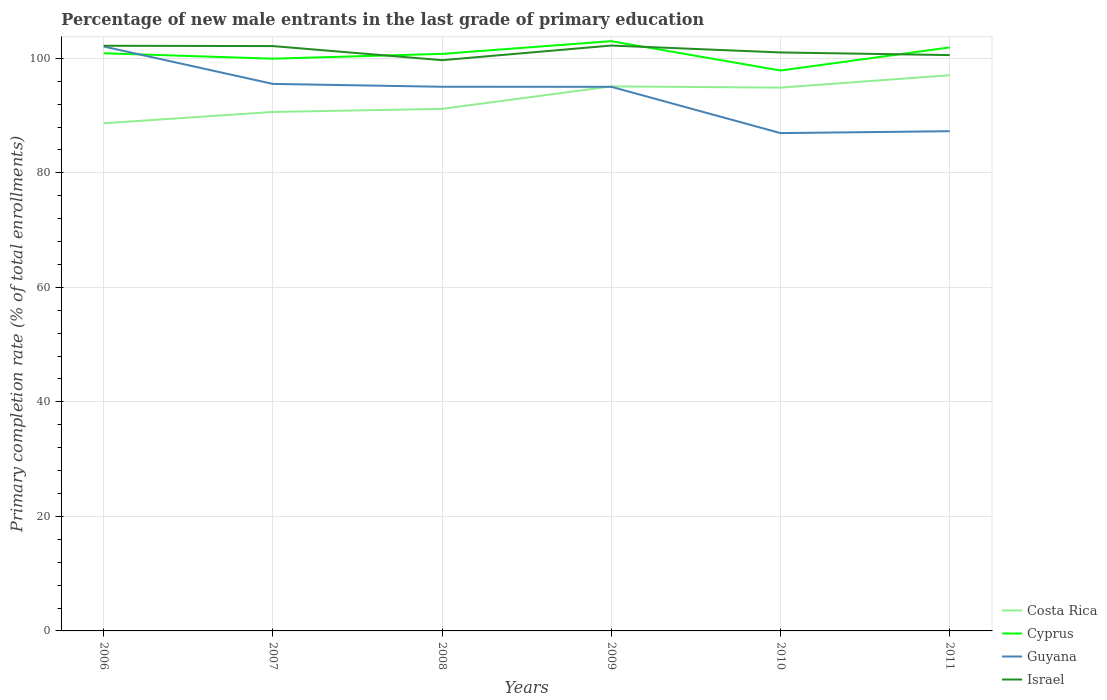How many different coloured lines are there?
Provide a short and direct response. 4. Does the line corresponding to Costa Rica intersect with the line corresponding to Israel?
Your answer should be compact. No. Across all years, what is the maximum percentage of new male entrants in Cyprus?
Offer a very short reply. 97.88. In which year was the percentage of new male entrants in Israel maximum?
Your answer should be very brief. 2008. What is the total percentage of new male entrants in Guyana in the graph?
Your response must be concise. -0.33. What is the difference between the highest and the second highest percentage of new male entrants in Cyprus?
Offer a very short reply. 5.12. What is the difference between the highest and the lowest percentage of new male entrants in Israel?
Your answer should be compact. 3. Is the percentage of new male entrants in Israel strictly greater than the percentage of new male entrants in Guyana over the years?
Your answer should be compact. No. How many lines are there?
Keep it short and to the point. 4. How many years are there in the graph?
Provide a succinct answer. 6. Are the values on the major ticks of Y-axis written in scientific E-notation?
Your response must be concise. No. Does the graph contain any zero values?
Provide a succinct answer. No. Does the graph contain grids?
Give a very brief answer. Yes. Where does the legend appear in the graph?
Make the answer very short. Bottom right. How many legend labels are there?
Provide a short and direct response. 4. What is the title of the graph?
Your answer should be very brief. Percentage of new male entrants in the last grade of primary education. What is the label or title of the Y-axis?
Ensure brevity in your answer.  Primary completion rate (% of total enrollments). What is the Primary completion rate (% of total enrollments) of Costa Rica in 2006?
Provide a short and direct response. 88.66. What is the Primary completion rate (% of total enrollments) of Cyprus in 2006?
Keep it short and to the point. 100.89. What is the Primary completion rate (% of total enrollments) in Guyana in 2006?
Your answer should be compact. 102.07. What is the Primary completion rate (% of total enrollments) of Israel in 2006?
Your answer should be compact. 102.2. What is the Primary completion rate (% of total enrollments) in Costa Rica in 2007?
Offer a very short reply. 90.64. What is the Primary completion rate (% of total enrollments) of Cyprus in 2007?
Offer a terse response. 99.94. What is the Primary completion rate (% of total enrollments) in Guyana in 2007?
Your response must be concise. 95.54. What is the Primary completion rate (% of total enrollments) in Israel in 2007?
Your answer should be compact. 102.15. What is the Primary completion rate (% of total enrollments) of Costa Rica in 2008?
Provide a succinct answer. 91.18. What is the Primary completion rate (% of total enrollments) of Cyprus in 2008?
Your answer should be very brief. 100.79. What is the Primary completion rate (% of total enrollments) of Guyana in 2008?
Provide a succinct answer. 95.04. What is the Primary completion rate (% of total enrollments) in Israel in 2008?
Your answer should be compact. 99.68. What is the Primary completion rate (% of total enrollments) in Costa Rica in 2009?
Provide a short and direct response. 95.1. What is the Primary completion rate (% of total enrollments) of Cyprus in 2009?
Provide a succinct answer. 103. What is the Primary completion rate (% of total enrollments) of Guyana in 2009?
Offer a terse response. 95.03. What is the Primary completion rate (% of total enrollments) of Israel in 2009?
Give a very brief answer. 102.24. What is the Primary completion rate (% of total enrollments) in Costa Rica in 2010?
Your answer should be very brief. 94.89. What is the Primary completion rate (% of total enrollments) in Cyprus in 2010?
Provide a succinct answer. 97.88. What is the Primary completion rate (% of total enrollments) of Guyana in 2010?
Your response must be concise. 86.94. What is the Primary completion rate (% of total enrollments) in Israel in 2010?
Ensure brevity in your answer.  101.03. What is the Primary completion rate (% of total enrollments) in Costa Rica in 2011?
Offer a very short reply. 97.06. What is the Primary completion rate (% of total enrollments) in Cyprus in 2011?
Ensure brevity in your answer.  101.91. What is the Primary completion rate (% of total enrollments) of Guyana in 2011?
Your answer should be compact. 87.28. What is the Primary completion rate (% of total enrollments) of Israel in 2011?
Your answer should be very brief. 100.57. Across all years, what is the maximum Primary completion rate (% of total enrollments) of Costa Rica?
Your response must be concise. 97.06. Across all years, what is the maximum Primary completion rate (% of total enrollments) in Cyprus?
Your answer should be compact. 103. Across all years, what is the maximum Primary completion rate (% of total enrollments) of Guyana?
Your response must be concise. 102.07. Across all years, what is the maximum Primary completion rate (% of total enrollments) of Israel?
Your answer should be compact. 102.24. Across all years, what is the minimum Primary completion rate (% of total enrollments) of Costa Rica?
Provide a succinct answer. 88.66. Across all years, what is the minimum Primary completion rate (% of total enrollments) of Cyprus?
Your response must be concise. 97.88. Across all years, what is the minimum Primary completion rate (% of total enrollments) in Guyana?
Your answer should be very brief. 86.94. Across all years, what is the minimum Primary completion rate (% of total enrollments) in Israel?
Your answer should be very brief. 99.68. What is the total Primary completion rate (% of total enrollments) in Costa Rica in the graph?
Your answer should be very brief. 557.54. What is the total Primary completion rate (% of total enrollments) in Cyprus in the graph?
Give a very brief answer. 604.42. What is the total Primary completion rate (% of total enrollments) of Guyana in the graph?
Your response must be concise. 561.9. What is the total Primary completion rate (% of total enrollments) in Israel in the graph?
Provide a short and direct response. 607.87. What is the difference between the Primary completion rate (% of total enrollments) in Costa Rica in 2006 and that in 2007?
Offer a very short reply. -1.98. What is the difference between the Primary completion rate (% of total enrollments) in Cyprus in 2006 and that in 2007?
Make the answer very short. 0.95. What is the difference between the Primary completion rate (% of total enrollments) of Guyana in 2006 and that in 2007?
Keep it short and to the point. 6.53. What is the difference between the Primary completion rate (% of total enrollments) of Israel in 2006 and that in 2007?
Provide a short and direct response. 0.05. What is the difference between the Primary completion rate (% of total enrollments) in Costa Rica in 2006 and that in 2008?
Provide a succinct answer. -2.52. What is the difference between the Primary completion rate (% of total enrollments) in Cyprus in 2006 and that in 2008?
Make the answer very short. 0.11. What is the difference between the Primary completion rate (% of total enrollments) of Guyana in 2006 and that in 2008?
Your answer should be compact. 7.03. What is the difference between the Primary completion rate (% of total enrollments) in Israel in 2006 and that in 2008?
Your answer should be very brief. 2.52. What is the difference between the Primary completion rate (% of total enrollments) of Costa Rica in 2006 and that in 2009?
Your answer should be very brief. -6.44. What is the difference between the Primary completion rate (% of total enrollments) in Cyprus in 2006 and that in 2009?
Provide a succinct answer. -2.11. What is the difference between the Primary completion rate (% of total enrollments) in Guyana in 2006 and that in 2009?
Provide a short and direct response. 7.04. What is the difference between the Primary completion rate (% of total enrollments) of Israel in 2006 and that in 2009?
Offer a very short reply. -0.04. What is the difference between the Primary completion rate (% of total enrollments) of Costa Rica in 2006 and that in 2010?
Offer a terse response. -6.23. What is the difference between the Primary completion rate (% of total enrollments) in Cyprus in 2006 and that in 2010?
Keep it short and to the point. 3.01. What is the difference between the Primary completion rate (% of total enrollments) of Guyana in 2006 and that in 2010?
Provide a short and direct response. 15.13. What is the difference between the Primary completion rate (% of total enrollments) of Israel in 2006 and that in 2010?
Make the answer very short. 1.17. What is the difference between the Primary completion rate (% of total enrollments) of Costa Rica in 2006 and that in 2011?
Your answer should be very brief. -8.4. What is the difference between the Primary completion rate (% of total enrollments) in Cyprus in 2006 and that in 2011?
Your response must be concise. -1.02. What is the difference between the Primary completion rate (% of total enrollments) of Guyana in 2006 and that in 2011?
Give a very brief answer. 14.79. What is the difference between the Primary completion rate (% of total enrollments) of Israel in 2006 and that in 2011?
Keep it short and to the point. 1.63. What is the difference between the Primary completion rate (% of total enrollments) in Costa Rica in 2007 and that in 2008?
Provide a succinct answer. -0.54. What is the difference between the Primary completion rate (% of total enrollments) of Cyprus in 2007 and that in 2008?
Give a very brief answer. -0.84. What is the difference between the Primary completion rate (% of total enrollments) in Guyana in 2007 and that in 2008?
Your answer should be very brief. 0.5. What is the difference between the Primary completion rate (% of total enrollments) in Israel in 2007 and that in 2008?
Ensure brevity in your answer.  2.46. What is the difference between the Primary completion rate (% of total enrollments) of Costa Rica in 2007 and that in 2009?
Provide a succinct answer. -4.46. What is the difference between the Primary completion rate (% of total enrollments) of Cyprus in 2007 and that in 2009?
Provide a short and direct response. -3.06. What is the difference between the Primary completion rate (% of total enrollments) of Guyana in 2007 and that in 2009?
Your response must be concise. 0.51. What is the difference between the Primary completion rate (% of total enrollments) of Israel in 2007 and that in 2009?
Give a very brief answer. -0.09. What is the difference between the Primary completion rate (% of total enrollments) in Costa Rica in 2007 and that in 2010?
Provide a short and direct response. -4.25. What is the difference between the Primary completion rate (% of total enrollments) in Cyprus in 2007 and that in 2010?
Your answer should be very brief. 2.06. What is the difference between the Primary completion rate (% of total enrollments) in Guyana in 2007 and that in 2010?
Your response must be concise. 8.59. What is the difference between the Primary completion rate (% of total enrollments) in Israel in 2007 and that in 2010?
Give a very brief answer. 1.11. What is the difference between the Primary completion rate (% of total enrollments) in Costa Rica in 2007 and that in 2011?
Ensure brevity in your answer.  -6.41. What is the difference between the Primary completion rate (% of total enrollments) of Cyprus in 2007 and that in 2011?
Your answer should be very brief. -1.97. What is the difference between the Primary completion rate (% of total enrollments) of Guyana in 2007 and that in 2011?
Provide a succinct answer. 8.26. What is the difference between the Primary completion rate (% of total enrollments) of Israel in 2007 and that in 2011?
Give a very brief answer. 1.57. What is the difference between the Primary completion rate (% of total enrollments) in Costa Rica in 2008 and that in 2009?
Make the answer very short. -3.92. What is the difference between the Primary completion rate (% of total enrollments) of Cyprus in 2008 and that in 2009?
Your response must be concise. -2.22. What is the difference between the Primary completion rate (% of total enrollments) of Guyana in 2008 and that in 2009?
Provide a short and direct response. 0.01. What is the difference between the Primary completion rate (% of total enrollments) of Israel in 2008 and that in 2009?
Provide a short and direct response. -2.56. What is the difference between the Primary completion rate (% of total enrollments) of Costa Rica in 2008 and that in 2010?
Provide a succinct answer. -3.71. What is the difference between the Primary completion rate (% of total enrollments) of Cyprus in 2008 and that in 2010?
Your answer should be compact. 2.91. What is the difference between the Primary completion rate (% of total enrollments) of Guyana in 2008 and that in 2010?
Give a very brief answer. 8.1. What is the difference between the Primary completion rate (% of total enrollments) of Israel in 2008 and that in 2010?
Provide a succinct answer. -1.35. What is the difference between the Primary completion rate (% of total enrollments) of Costa Rica in 2008 and that in 2011?
Provide a short and direct response. -5.88. What is the difference between the Primary completion rate (% of total enrollments) of Cyprus in 2008 and that in 2011?
Your answer should be very brief. -1.12. What is the difference between the Primary completion rate (% of total enrollments) of Guyana in 2008 and that in 2011?
Your answer should be very brief. 7.76. What is the difference between the Primary completion rate (% of total enrollments) in Israel in 2008 and that in 2011?
Provide a short and direct response. -0.89. What is the difference between the Primary completion rate (% of total enrollments) of Costa Rica in 2009 and that in 2010?
Keep it short and to the point. 0.21. What is the difference between the Primary completion rate (% of total enrollments) in Cyprus in 2009 and that in 2010?
Keep it short and to the point. 5.12. What is the difference between the Primary completion rate (% of total enrollments) in Guyana in 2009 and that in 2010?
Keep it short and to the point. 8.09. What is the difference between the Primary completion rate (% of total enrollments) of Israel in 2009 and that in 2010?
Provide a succinct answer. 1.21. What is the difference between the Primary completion rate (% of total enrollments) in Costa Rica in 2009 and that in 2011?
Provide a succinct answer. -1.95. What is the difference between the Primary completion rate (% of total enrollments) in Cyprus in 2009 and that in 2011?
Your answer should be very brief. 1.09. What is the difference between the Primary completion rate (% of total enrollments) in Guyana in 2009 and that in 2011?
Offer a terse response. 7.75. What is the difference between the Primary completion rate (% of total enrollments) of Israel in 2009 and that in 2011?
Your response must be concise. 1.67. What is the difference between the Primary completion rate (% of total enrollments) in Costa Rica in 2010 and that in 2011?
Provide a short and direct response. -2.17. What is the difference between the Primary completion rate (% of total enrollments) of Cyprus in 2010 and that in 2011?
Your response must be concise. -4.03. What is the difference between the Primary completion rate (% of total enrollments) of Guyana in 2010 and that in 2011?
Your response must be concise. -0.33. What is the difference between the Primary completion rate (% of total enrollments) in Israel in 2010 and that in 2011?
Keep it short and to the point. 0.46. What is the difference between the Primary completion rate (% of total enrollments) in Costa Rica in 2006 and the Primary completion rate (% of total enrollments) in Cyprus in 2007?
Offer a very short reply. -11.28. What is the difference between the Primary completion rate (% of total enrollments) of Costa Rica in 2006 and the Primary completion rate (% of total enrollments) of Guyana in 2007?
Offer a terse response. -6.88. What is the difference between the Primary completion rate (% of total enrollments) of Costa Rica in 2006 and the Primary completion rate (% of total enrollments) of Israel in 2007?
Give a very brief answer. -13.48. What is the difference between the Primary completion rate (% of total enrollments) in Cyprus in 2006 and the Primary completion rate (% of total enrollments) in Guyana in 2007?
Offer a very short reply. 5.35. What is the difference between the Primary completion rate (% of total enrollments) in Cyprus in 2006 and the Primary completion rate (% of total enrollments) in Israel in 2007?
Your response must be concise. -1.25. What is the difference between the Primary completion rate (% of total enrollments) of Guyana in 2006 and the Primary completion rate (% of total enrollments) of Israel in 2007?
Make the answer very short. -0.07. What is the difference between the Primary completion rate (% of total enrollments) in Costa Rica in 2006 and the Primary completion rate (% of total enrollments) in Cyprus in 2008?
Provide a succinct answer. -12.12. What is the difference between the Primary completion rate (% of total enrollments) of Costa Rica in 2006 and the Primary completion rate (% of total enrollments) of Guyana in 2008?
Offer a terse response. -6.38. What is the difference between the Primary completion rate (% of total enrollments) in Costa Rica in 2006 and the Primary completion rate (% of total enrollments) in Israel in 2008?
Provide a short and direct response. -11.02. What is the difference between the Primary completion rate (% of total enrollments) in Cyprus in 2006 and the Primary completion rate (% of total enrollments) in Guyana in 2008?
Your answer should be compact. 5.85. What is the difference between the Primary completion rate (% of total enrollments) of Cyprus in 2006 and the Primary completion rate (% of total enrollments) of Israel in 2008?
Your answer should be very brief. 1.21. What is the difference between the Primary completion rate (% of total enrollments) of Guyana in 2006 and the Primary completion rate (% of total enrollments) of Israel in 2008?
Give a very brief answer. 2.39. What is the difference between the Primary completion rate (% of total enrollments) in Costa Rica in 2006 and the Primary completion rate (% of total enrollments) in Cyprus in 2009?
Keep it short and to the point. -14.34. What is the difference between the Primary completion rate (% of total enrollments) in Costa Rica in 2006 and the Primary completion rate (% of total enrollments) in Guyana in 2009?
Keep it short and to the point. -6.37. What is the difference between the Primary completion rate (% of total enrollments) in Costa Rica in 2006 and the Primary completion rate (% of total enrollments) in Israel in 2009?
Give a very brief answer. -13.58. What is the difference between the Primary completion rate (% of total enrollments) in Cyprus in 2006 and the Primary completion rate (% of total enrollments) in Guyana in 2009?
Keep it short and to the point. 5.86. What is the difference between the Primary completion rate (% of total enrollments) in Cyprus in 2006 and the Primary completion rate (% of total enrollments) in Israel in 2009?
Make the answer very short. -1.35. What is the difference between the Primary completion rate (% of total enrollments) of Guyana in 2006 and the Primary completion rate (% of total enrollments) of Israel in 2009?
Your answer should be compact. -0.17. What is the difference between the Primary completion rate (% of total enrollments) of Costa Rica in 2006 and the Primary completion rate (% of total enrollments) of Cyprus in 2010?
Provide a short and direct response. -9.22. What is the difference between the Primary completion rate (% of total enrollments) of Costa Rica in 2006 and the Primary completion rate (% of total enrollments) of Guyana in 2010?
Keep it short and to the point. 1.72. What is the difference between the Primary completion rate (% of total enrollments) in Costa Rica in 2006 and the Primary completion rate (% of total enrollments) in Israel in 2010?
Your answer should be compact. -12.37. What is the difference between the Primary completion rate (% of total enrollments) of Cyprus in 2006 and the Primary completion rate (% of total enrollments) of Guyana in 2010?
Offer a very short reply. 13.95. What is the difference between the Primary completion rate (% of total enrollments) in Cyprus in 2006 and the Primary completion rate (% of total enrollments) in Israel in 2010?
Keep it short and to the point. -0.14. What is the difference between the Primary completion rate (% of total enrollments) of Guyana in 2006 and the Primary completion rate (% of total enrollments) of Israel in 2010?
Provide a short and direct response. 1.04. What is the difference between the Primary completion rate (% of total enrollments) of Costa Rica in 2006 and the Primary completion rate (% of total enrollments) of Cyprus in 2011?
Offer a very short reply. -13.25. What is the difference between the Primary completion rate (% of total enrollments) of Costa Rica in 2006 and the Primary completion rate (% of total enrollments) of Guyana in 2011?
Your response must be concise. 1.39. What is the difference between the Primary completion rate (% of total enrollments) in Costa Rica in 2006 and the Primary completion rate (% of total enrollments) in Israel in 2011?
Your answer should be very brief. -11.91. What is the difference between the Primary completion rate (% of total enrollments) in Cyprus in 2006 and the Primary completion rate (% of total enrollments) in Guyana in 2011?
Keep it short and to the point. 13.62. What is the difference between the Primary completion rate (% of total enrollments) in Cyprus in 2006 and the Primary completion rate (% of total enrollments) in Israel in 2011?
Provide a short and direct response. 0.32. What is the difference between the Primary completion rate (% of total enrollments) in Guyana in 2006 and the Primary completion rate (% of total enrollments) in Israel in 2011?
Provide a succinct answer. 1.5. What is the difference between the Primary completion rate (% of total enrollments) of Costa Rica in 2007 and the Primary completion rate (% of total enrollments) of Cyprus in 2008?
Offer a terse response. -10.14. What is the difference between the Primary completion rate (% of total enrollments) of Costa Rica in 2007 and the Primary completion rate (% of total enrollments) of Guyana in 2008?
Your answer should be compact. -4.4. What is the difference between the Primary completion rate (% of total enrollments) in Costa Rica in 2007 and the Primary completion rate (% of total enrollments) in Israel in 2008?
Ensure brevity in your answer.  -9.04. What is the difference between the Primary completion rate (% of total enrollments) of Cyprus in 2007 and the Primary completion rate (% of total enrollments) of Guyana in 2008?
Offer a terse response. 4.9. What is the difference between the Primary completion rate (% of total enrollments) in Cyprus in 2007 and the Primary completion rate (% of total enrollments) in Israel in 2008?
Offer a terse response. 0.26. What is the difference between the Primary completion rate (% of total enrollments) in Guyana in 2007 and the Primary completion rate (% of total enrollments) in Israel in 2008?
Provide a succinct answer. -4.15. What is the difference between the Primary completion rate (% of total enrollments) in Costa Rica in 2007 and the Primary completion rate (% of total enrollments) in Cyprus in 2009?
Make the answer very short. -12.36. What is the difference between the Primary completion rate (% of total enrollments) of Costa Rica in 2007 and the Primary completion rate (% of total enrollments) of Guyana in 2009?
Keep it short and to the point. -4.39. What is the difference between the Primary completion rate (% of total enrollments) in Costa Rica in 2007 and the Primary completion rate (% of total enrollments) in Israel in 2009?
Ensure brevity in your answer.  -11.6. What is the difference between the Primary completion rate (% of total enrollments) of Cyprus in 2007 and the Primary completion rate (% of total enrollments) of Guyana in 2009?
Give a very brief answer. 4.91. What is the difference between the Primary completion rate (% of total enrollments) in Cyprus in 2007 and the Primary completion rate (% of total enrollments) in Israel in 2009?
Ensure brevity in your answer.  -2.3. What is the difference between the Primary completion rate (% of total enrollments) in Guyana in 2007 and the Primary completion rate (% of total enrollments) in Israel in 2009?
Keep it short and to the point. -6.7. What is the difference between the Primary completion rate (% of total enrollments) of Costa Rica in 2007 and the Primary completion rate (% of total enrollments) of Cyprus in 2010?
Offer a very short reply. -7.24. What is the difference between the Primary completion rate (% of total enrollments) in Costa Rica in 2007 and the Primary completion rate (% of total enrollments) in Guyana in 2010?
Provide a succinct answer. 3.7. What is the difference between the Primary completion rate (% of total enrollments) in Costa Rica in 2007 and the Primary completion rate (% of total enrollments) in Israel in 2010?
Your answer should be compact. -10.39. What is the difference between the Primary completion rate (% of total enrollments) of Cyprus in 2007 and the Primary completion rate (% of total enrollments) of Guyana in 2010?
Ensure brevity in your answer.  13. What is the difference between the Primary completion rate (% of total enrollments) in Cyprus in 2007 and the Primary completion rate (% of total enrollments) in Israel in 2010?
Offer a terse response. -1.09. What is the difference between the Primary completion rate (% of total enrollments) of Guyana in 2007 and the Primary completion rate (% of total enrollments) of Israel in 2010?
Offer a terse response. -5.49. What is the difference between the Primary completion rate (% of total enrollments) in Costa Rica in 2007 and the Primary completion rate (% of total enrollments) in Cyprus in 2011?
Provide a short and direct response. -11.27. What is the difference between the Primary completion rate (% of total enrollments) of Costa Rica in 2007 and the Primary completion rate (% of total enrollments) of Guyana in 2011?
Make the answer very short. 3.37. What is the difference between the Primary completion rate (% of total enrollments) in Costa Rica in 2007 and the Primary completion rate (% of total enrollments) in Israel in 2011?
Ensure brevity in your answer.  -9.93. What is the difference between the Primary completion rate (% of total enrollments) in Cyprus in 2007 and the Primary completion rate (% of total enrollments) in Guyana in 2011?
Make the answer very short. 12.67. What is the difference between the Primary completion rate (% of total enrollments) of Cyprus in 2007 and the Primary completion rate (% of total enrollments) of Israel in 2011?
Give a very brief answer. -0.63. What is the difference between the Primary completion rate (% of total enrollments) in Guyana in 2007 and the Primary completion rate (% of total enrollments) in Israel in 2011?
Provide a succinct answer. -5.03. What is the difference between the Primary completion rate (% of total enrollments) in Costa Rica in 2008 and the Primary completion rate (% of total enrollments) in Cyprus in 2009?
Your answer should be compact. -11.82. What is the difference between the Primary completion rate (% of total enrollments) of Costa Rica in 2008 and the Primary completion rate (% of total enrollments) of Guyana in 2009?
Your answer should be compact. -3.85. What is the difference between the Primary completion rate (% of total enrollments) in Costa Rica in 2008 and the Primary completion rate (% of total enrollments) in Israel in 2009?
Your response must be concise. -11.06. What is the difference between the Primary completion rate (% of total enrollments) of Cyprus in 2008 and the Primary completion rate (% of total enrollments) of Guyana in 2009?
Provide a succinct answer. 5.75. What is the difference between the Primary completion rate (% of total enrollments) of Cyprus in 2008 and the Primary completion rate (% of total enrollments) of Israel in 2009?
Ensure brevity in your answer.  -1.45. What is the difference between the Primary completion rate (% of total enrollments) in Guyana in 2008 and the Primary completion rate (% of total enrollments) in Israel in 2009?
Your response must be concise. -7.2. What is the difference between the Primary completion rate (% of total enrollments) in Costa Rica in 2008 and the Primary completion rate (% of total enrollments) in Cyprus in 2010?
Your response must be concise. -6.7. What is the difference between the Primary completion rate (% of total enrollments) of Costa Rica in 2008 and the Primary completion rate (% of total enrollments) of Guyana in 2010?
Provide a succinct answer. 4.24. What is the difference between the Primary completion rate (% of total enrollments) in Costa Rica in 2008 and the Primary completion rate (% of total enrollments) in Israel in 2010?
Offer a terse response. -9.85. What is the difference between the Primary completion rate (% of total enrollments) of Cyprus in 2008 and the Primary completion rate (% of total enrollments) of Guyana in 2010?
Your answer should be very brief. 13.84. What is the difference between the Primary completion rate (% of total enrollments) of Cyprus in 2008 and the Primary completion rate (% of total enrollments) of Israel in 2010?
Your answer should be very brief. -0.24. What is the difference between the Primary completion rate (% of total enrollments) in Guyana in 2008 and the Primary completion rate (% of total enrollments) in Israel in 2010?
Your answer should be compact. -5.99. What is the difference between the Primary completion rate (% of total enrollments) of Costa Rica in 2008 and the Primary completion rate (% of total enrollments) of Cyprus in 2011?
Provide a succinct answer. -10.73. What is the difference between the Primary completion rate (% of total enrollments) of Costa Rica in 2008 and the Primary completion rate (% of total enrollments) of Guyana in 2011?
Offer a very short reply. 3.9. What is the difference between the Primary completion rate (% of total enrollments) of Costa Rica in 2008 and the Primary completion rate (% of total enrollments) of Israel in 2011?
Give a very brief answer. -9.39. What is the difference between the Primary completion rate (% of total enrollments) in Cyprus in 2008 and the Primary completion rate (% of total enrollments) in Guyana in 2011?
Your answer should be compact. 13.51. What is the difference between the Primary completion rate (% of total enrollments) in Cyprus in 2008 and the Primary completion rate (% of total enrollments) in Israel in 2011?
Your answer should be very brief. 0.22. What is the difference between the Primary completion rate (% of total enrollments) of Guyana in 2008 and the Primary completion rate (% of total enrollments) of Israel in 2011?
Ensure brevity in your answer.  -5.53. What is the difference between the Primary completion rate (% of total enrollments) in Costa Rica in 2009 and the Primary completion rate (% of total enrollments) in Cyprus in 2010?
Your response must be concise. -2.77. What is the difference between the Primary completion rate (% of total enrollments) in Costa Rica in 2009 and the Primary completion rate (% of total enrollments) in Guyana in 2010?
Keep it short and to the point. 8.16. What is the difference between the Primary completion rate (% of total enrollments) in Costa Rica in 2009 and the Primary completion rate (% of total enrollments) in Israel in 2010?
Keep it short and to the point. -5.93. What is the difference between the Primary completion rate (% of total enrollments) of Cyprus in 2009 and the Primary completion rate (% of total enrollments) of Guyana in 2010?
Ensure brevity in your answer.  16.06. What is the difference between the Primary completion rate (% of total enrollments) in Cyprus in 2009 and the Primary completion rate (% of total enrollments) in Israel in 2010?
Your answer should be compact. 1.97. What is the difference between the Primary completion rate (% of total enrollments) in Guyana in 2009 and the Primary completion rate (% of total enrollments) in Israel in 2010?
Your response must be concise. -6. What is the difference between the Primary completion rate (% of total enrollments) of Costa Rica in 2009 and the Primary completion rate (% of total enrollments) of Cyprus in 2011?
Give a very brief answer. -6.81. What is the difference between the Primary completion rate (% of total enrollments) of Costa Rica in 2009 and the Primary completion rate (% of total enrollments) of Guyana in 2011?
Offer a terse response. 7.83. What is the difference between the Primary completion rate (% of total enrollments) of Costa Rica in 2009 and the Primary completion rate (% of total enrollments) of Israel in 2011?
Ensure brevity in your answer.  -5.47. What is the difference between the Primary completion rate (% of total enrollments) of Cyprus in 2009 and the Primary completion rate (% of total enrollments) of Guyana in 2011?
Give a very brief answer. 15.72. What is the difference between the Primary completion rate (% of total enrollments) of Cyprus in 2009 and the Primary completion rate (% of total enrollments) of Israel in 2011?
Provide a short and direct response. 2.43. What is the difference between the Primary completion rate (% of total enrollments) in Guyana in 2009 and the Primary completion rate (% of total enrollments) in Israel in 2011?
Make the answer very short. -5.54. What is the difference between the Primary completion rate (% of total enrollments) in Costa Rica in 2010 and the Primary completion rate (% of total enrollments) in Cyprus in 2011?
Offer a terse response. -7.02. What is the difference between the Primary completion rate (% of total enrollments) of Costa Rica in 2010 and the Primary completion rate (% of total enrollments) of Guyana in 2011?
Ensure brevity in your answer.  7.61. What is the difference between the Primary completion rate (% of total enrollments) in Costa Rica in 2010 and the Primary completion rate (% of total enrollments) in Israel in 2011?
Offer a terse response. -5.68. What is the difference between the Primary completion rate (% of total enrollments) in Cyprus in 2010 and the Primary completion rate (% of total enrollments) in Guyana in 2011?
Your answer should be compact. 10.6. What is the difference between the Primary completion rate (% of total enrollments) of Cyprus in 2010 and the Primary completion rate (% of total enrollments) of Israel in 2011?
Offer a terse response. -2.69. What is the difference between the Primary completion rate (% of total enrollments) of Guyana in 2010 and the Primary completion rate (% of total enrollments) of Israel in 2011?
Your answer should be compact. -13.63. What is the average Primary completion rate (% of total enrollments) in Costa Rica per year?
Offer a very short reply. 92.92. What is the average Primary completion rate (% of total enrollments) of Cyprus per year?
Keep it short and to the point. 100.74. What is the average Primary completion rate (% of total enrollments) in Guyana per year?
Your answer should be compact. 93.65. What is the average Primary completion rate (% of total enrollments) of Israel per year?
Your answer should be compact. 101.31. In the year 2006, what is the difference between the Primary completion rate (% of total enrollments) of Costa Rica and Primary completion rate (% of total enrollments) of Cyprus?
Your response must be concise. -12.23. In the year 2006, what is the difference between the Primary completion rate (% of total enrollments) in Costa Rica and Primary completion rate (% of total enrollments) in Guyana?
Provide a short and direct response. -13.41. In the year 2006, what is the difference between the Primary completion rate (% of total enrollments) in Costa Rica and Primary completion rate (% of total enrollments) in Israel?
Offer a very short reply. -13.54. In the year 2006, what is the difference between the Primary completion rate (% of total enrollments) in Cyprus and Primary completion rate (% of total enrollments) in Guyana?
Ensure brevity in your answer.  -1.18. In the year 2006, what is the difference between the Primary completion rate (% of total enrollments) of Cyprus and Primary completion rate (% of total enrollments) of Israel?
Offer a terse response. -1.31. In the year 2006, what is the difference between the Primary completion rate (% of total enrollments) of Guyana and Primary completion rate (% of total enrollments) of Israel?
Provide a short and direct response. -0.13. In the year 2007, what is the difference between the Primary completion rate (% of total enrollments) in Costa Rica and Primary completion rate (% of total enrollments) in Cyprus?
Ensure brevity in your answer.  -9.3. In the year 2007, what is the difference between the Primary completion rate (% of total enrollments) in Costa Rica and Primary completion rate (% of total enrollments) in Guyana?
Your response must be concise. -4.89. In the year 2007, what is the difference between the Primary completion rate (% of total enrollments) in Costa Rica and Primary completion rate (% of total enrollments) in Israel?
Offer a very short reply. -11.5. In the year 2007, what is the difference between the Primary completion rate (% of total enrollments) in Cyprus and Primary completion rate (% of total enrollments) in Guyana?
Offer a terse response. 4.41. In the year 2007, what is the difference between the Primary completion rate (% of total enrollments) in Cyprus and Primary completion rate (% of total enrollments) in Israel?
Your response must be concise. -2.2. In the year 2007, what is the difference between the Primary completion rate (% of total enrollments) of Guyana and Primary completion rate (% of total enrollments) of Israel?
Your answer should be very brief. -6.61. In the year 2008, what is the difference between the Primary completion rate (% of total enrollments) in Costa Rica and Primary completion rate (% of total enrollments) in Cyprus?
Keep it short and to the point. -9.61. In the year 2008, what is the difference between the Primary completion rate (% of total enrollments) of Costa Rica and Primary completion rate (% of total enrollments) of Guyana?
Offer a very short reply. -3.86. In the year 2008, what is the difference between the Primary completion rate (% of total enrollments) in Costa Rica and Primary completion rate (% of total enrollments) in Israel?
Your answer should be compact. -8.5. In the year 2008, what is the difference between the Primary completion rate (% of total enrollments) of Cyprus and Primary completion rate (% of total enrollments) of Guyana?
Make the answer very short. 5.75. In the year 2008, what is the difference between the Primary completion rate (% of total enrollments) in Cyprus and Primary completion rate (% of total enrollments) in Israel?
Make the answer very short. 1.1. In the year 2008, what is the difference between the Primary completion rate (% of total enrollments) of Guyana and Primary completion rate (% of total enrollments) of Israel?
Give a very brief answer. -4.64. In the year 2009, what is the difference between the Primary completion rate (% of total enrollments) of Costa Rica and Primary completion rate (% of total enrollments) of Cyprus?
Provide a succinct answer. -7.9. In the year 2009, what is the difference between the Primary completion rate (% of total enrollments) in Costa Rica and Primary completion rate (% of total enrollments) in Guyana?
Offer a very short reply. 0.07. In the year 2009, what is the difference between the Primary completion rate (% of total enrollments) in Costa Rica and Primary completion rate (% of total enrollments) in Israel?
Make the answer very short. -7.14. In the year 2009, what is the difference between the Primary completion rate (% of total enrollments) in Cyprus and Primary completion rate (% of total enrollments) in Guyana?
Offer a terse response. 7.97. In the year 2009, what is the difference between the Primary completion rate (% of total enrollments) of Cyprus and Primary completion rate (% of total enrollments) of Israel?
Your answer should be very brief. 0.76. In the year 2009, what is the difference between the Primary completion rate (% of total enrollments) in Guyana and Primary completion rate (% of total enrollments) in Israel?
Provide a short and direct response. -7.21. In the year 2010, what is the difference between the Primary completion rate (% of total enrollments) of Costa Rica and Primary completion rate (% of total enrollments) of Cyprus?
Keep it short and to the point. -2.99. In the year 2010, what is the difference between the Primary completion rate (% of total enrollments) of Costa Rica and Primary completion rate (% of total enrollments) of Guyana?
Your response must be concise. 7.95. In the year 2010, what is the difference between the Primary completion rate (% of total enrollments) in Costa Rica and Primary completion rate (% of total enrollments) in Israel?
Give a very brief answer. -6.14. In the year 2010, what is the difference between the Primary completion rate (% of total enrollments) of Cyprus and Primary completion rate (% of total enrollments) of Guyana?
Your response must be concise. 10.93. In the year 2010, what is the difference between the Primary completion rate (% of total enrollments) in Cyprus and Primary completion rate (% of total enrollments) in Israel?
Your response must be concise. -3.15. In the year 2010, what is the difference between the Primary completion rate (% of total enrollments) of Guyana and Primary completion rate (% of total enrollments) of Israel?
Make the answer very short. -14.09. In the year 2011, what is the difference between the Primary completion rate (% of total enrollments) in Costa Rica and Primary completion rate (% of total enrollments) in Cyprus?
Your answer should be compact. -4.85. In the year 2011, what is the difference between the Primary completion rate (% of total enrollments) in Costa Rica and Primary completion rate (% of total enrollments) in Guyana?
Make the answer very short. 9.78. In the year 2011, what is the difference between the Primary completion rate (% of total enrollments) of Costa Rica and Primary completion rate (% of total enrollments) of Israel?
Offer a terse response. -3.51. In the year 2011, what is the difference between the Primary completion rate (% of total enrollments) of Cyprus and Primary completion rate (% of total enrollments) of Guyana?
Your answer should be very brief. 14.63. In the year 2011, what is the difference between the Primary completion rate (% of total enrollments) of Cyprus and Primary completion rate (% of total enrollments) of Israel?
Offer a terse response. 1.34. In the year 2011, what is the difference between the Primary completion rate (% of total enrollments) of Guyana and Primary completion rate (% of total enrollments) of Israel?
Give a very brief answer. -13.29. What is the ratio of the Primary completion rate (% of total enrollments) of Costa Rica in 2006 to that in 2007?
Ensure brevity in your answer.  0.98. What is the ratio of the Primary completion rate (% of total enrollments) in Cyprus in 2006 to that in 2007?
Ensure brevity in your answer.  1.01. What is the ratio of the Primary completion rate (% of total enrollments) of Guyana in 2006 to that in 2007?
Keep it short and to the point. 1.07. What is the ratio of the Primary completion rate (% of total enrollments) of Israel in 2006 to that in 2007?
Your answer should be compact. 1. What is the ratio of the Primary completion rate (% of total enrollments) in Costa Rica in 2006 to that in 2008?
Your response must be concise. 0.97. What is the ratio of the Primary completion rate (% of total enrollments) of Guyana in 2006 to that in 2008?
Your response must be concise. 1.07. What is the ratio of the Primary completion rate (% of total enrollments) of Israel in 2006 to that in 2008?
Provide a succinct answer. 1.03. What is the ratio of the Primary completion rate (% of total enrollments) of Costa Rica in 2006 to that in 2009?
Your response must be concise. 0.93. What is the ratio of the Primary completion rate (% of total enrollments) of Cyprus in 2006 to that in 2009?
Your answer should be compact. 0.98. What is the ratio of the Primary completion rate (% of total enrollments) in Guyana in 2006 to that in 2009?
Ensure brevity in your answer.  1.07. What is the ratio of the Primary completion rate (% of total enrollments) of Israel in 2006 to that in 2009?
Keep it short and to the point. 1. What is the ratio of the Primary completion rate (% of total enrollments) of Costa Rica in 2006 to that in 2010?
Keep it short and to the point. 0.93. What is the ratio of the Primary completion rate (% of total enrollments) of Cyprus in 2006 to that in 2010?
Your answer should be compact. 1.03. What is the ratio of the Primary completion rate (% of total enrollments) of Guyana in 2006 to that in 2010?
Keep it short and to the point. 1.17. What is the ratio of the Primary completion rate (% of total enrollments) in Israel in 2006 to that in 2010?
Your answer should be very brief. 1.01. What is the ratio of the Primary completion rate (% of total enrollments) in Costa Rica in 2006 to that in 2011?
Provide a succinct answer. 0.91. What is the ratio of the Primary completion rate (% of total enrollments) of Cyprus in 2006 to that in 2011?
Make the answer very short. 0.99. What is the ratio of the Primary completion rate (% of total enrollments) of Guyana in 2006 to that in 2011?
Make the answer very short. 1.17. What is the ratio of the Primary completion rate (% of total enrollments) in Israel in 2006 to that in 2011?
Keep it short and to the point. 1.02. What is the ratio of the Primary completion rate (% of total enrollments) in Costa Rica in 2007 to that in 2008?
Your answer should be compact. 0.99. What is the ratio of the Primary completion rate (% of total enrollments) in Israel in 2007 to that in 2008?
Your answer should be very brief. 1.02. What is the ratio of the Primary completion rate (% of total enrollments) of Costa Rica in 2007 to that in 2009?
Provide a short and direct response. 0.95. What is the ratio of the Primary completion rate (% of total enrollments) of Cyprus in 2007 to that in 2009?
Make the answer very short. 0.97. What is the ratio of the Primary completion rate (% of total enrollments) of Costa Rica in 2007 to that in 2010?
Provide a short and direct response. 0.96. What is the ratio of the Primary completion rate (% of total enrollments) in Cyprus in 2007 to that in 2010?
Your answer should be very brief. 1.02. What is the ratio of the Primary completion rate (% of total enrollments) in Guyana in 2007 to that in 2010?
Offer a very short reply. 1.1. What is the ratio of the Primary completion rate (% of total enrollments) in Israel in 2007 to that in 2010?
Provide a succinct answer. 1.01. What is the ratio of the Primary completion rate (% of total enrollments) of Costa Rica in 2007 to that in 2011?
Your answer should be very brief. 0.93. What is the ratio of the Primary completion rate (% of total enrollments) in Cyprus in 2007 to that in 2011?
Keep it short and to the point. 0.98. What is the ratio of the Primary completion rate (% of total enrollments) of Guyana in 2007 to that in 2011?
Offer a very short reply. 1.09. What is the ratio of the Primary completion rate (% of total enrollments) in Israel in 2007 to that in 2011?
Your answer should be compact. 1.02. What is the ratio of the Primary completion rate (% of total enrollments) of Costa Rica in 2008 to that in 2009?
Offer a very short reply. 0.96. What is the ratio of the Primary completion rate (% of total enrollments) of Cyprus in 2008 to that in 2009?
Offer a very short reply. 0.98. What is the ratio of the Primary completion rate (% of total enrollments) of Guyana in 2008 to that in 2009?
Offer a very short reply. 1. What is the ratio of the Primary completion rate (% of total enrollments) in Costa Rica in 2008 to that in 2010?
Offer a very short reply. 0.96. What is the ratio of the Primary completion rate (% of total enrollments) in Cyprus in 2008 to that in 2010?
Offer a terse response. 1.03. What is the ratio of the Primary completion rate (% of total enrollments) of Guyana in 2008 to that in 2010?
Give a very brief answer. 1.09. What is the ratio of the Primary completion rate (% of total enrollments) in Israel in 2008 to that in 2010?
Ensure brevity in your answer.  0.99. What is the ratio of the Primary completion rate (% of total enrollments) in Costa Rica in 2008 to that in 2011?
Ensure brevity in your answer.  0.94. What is the ratio of the Primary completion rate (% of total enrollments) in Guyana in 2008 to that in 2011?
Offer a terse response. 1.09. What is the ratio of the Primary completion rate (% of total enrollments) of Israel in 2008 to that in 2011?
Offer a very short reply. 0.99. What is the ratio of the Primary completion rate (% of total enrollments) of Cyprus in 2009 to that in 2010?
Ensure brevity in your answer.  1.05. What is the ratio of the Primary completion rate (% of total enrollments) in Guyana in 2009 to that in 2010?
Ensure brevity in your answer.  1.09. What is the ratio of the Primary completion rate (% of total enrollments) in Costa Rica in 2009 to that in 2011?
Your answer should be very brief. 0.98. What is the ratio of the Primary completion rate (% of total enrollments) in Cyprus in 2009 to that in 2011?
Offer a terse response. 1.01. What is the ratio of the Primary completion rate (% of total enrollments) in Guyana in 2009 to that in 2011?
Your answer should be very brief. 1.09. What is the ratio of the Primary completion rate (% of total enrollments) in Israel in 2009 to that in 2011?
Keep it short and to the point. 1.02. What is the ratio of the Primary completion rate (% of total enrollments) of Costa Rica in 2010 to that in 2011?
Offer a terse response. 0.98. What is the ratio of the Primary completion rate (% of total enrollments) in Cyprus in 2010 to that in 2011?
Provide a succinct answer. 0.96. What is the ratio of the Primary completion rate (% of total enrollments) of Guyana in 2010 to that in 2011?
Your answer should be compact. 1. What is the ratio of the Primary completion rate (% of total enrollments) of Israel in 2010 to that in 2011?
Your answer should be very brief. 1. What is the difference between the highest and the second highest Primary completion rate (% of total enrollments) in Costa Rica?
Ensure brevity in your answer.  1.95. What is the difference between the highest and the second highest Primary completion rate (% of total enrollments) in Cyprus?
Provide a succinct answer. 1.09. What is the difference between the highest and the second highest Primary completion rate (% of total enrollments) of Guyana?
Your answer should be compact. 6.53. What is the difference between the highest and the second highest Primary completion rate (% of total enrollments) in Israel?
Your answer should be compact. 0.04. What is the difference between the highest and the lowest Primary completion rate (% of total enrollments) in Costa Rica?
Offer a terse response. 8.4. What is the difference between the highest and the lowest Primary completion rate (% of total enrollments) of Cyprus?
Ensure brevity in your answer.  5.12. What is the difference between the highest and the lowest Primary completion rate (% of total enrollments) in Guyana?
Ensure brevity in your answer.  15.13. What is the difference between the highest and the lowest Primary completion rate (% of total enrollments) in Israel?
Your answer should be compact. 2.56. 